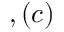Convert formula to latex. <formula><loc_0><loc_0><loc_500><loc_500>, ( c )</formula> 